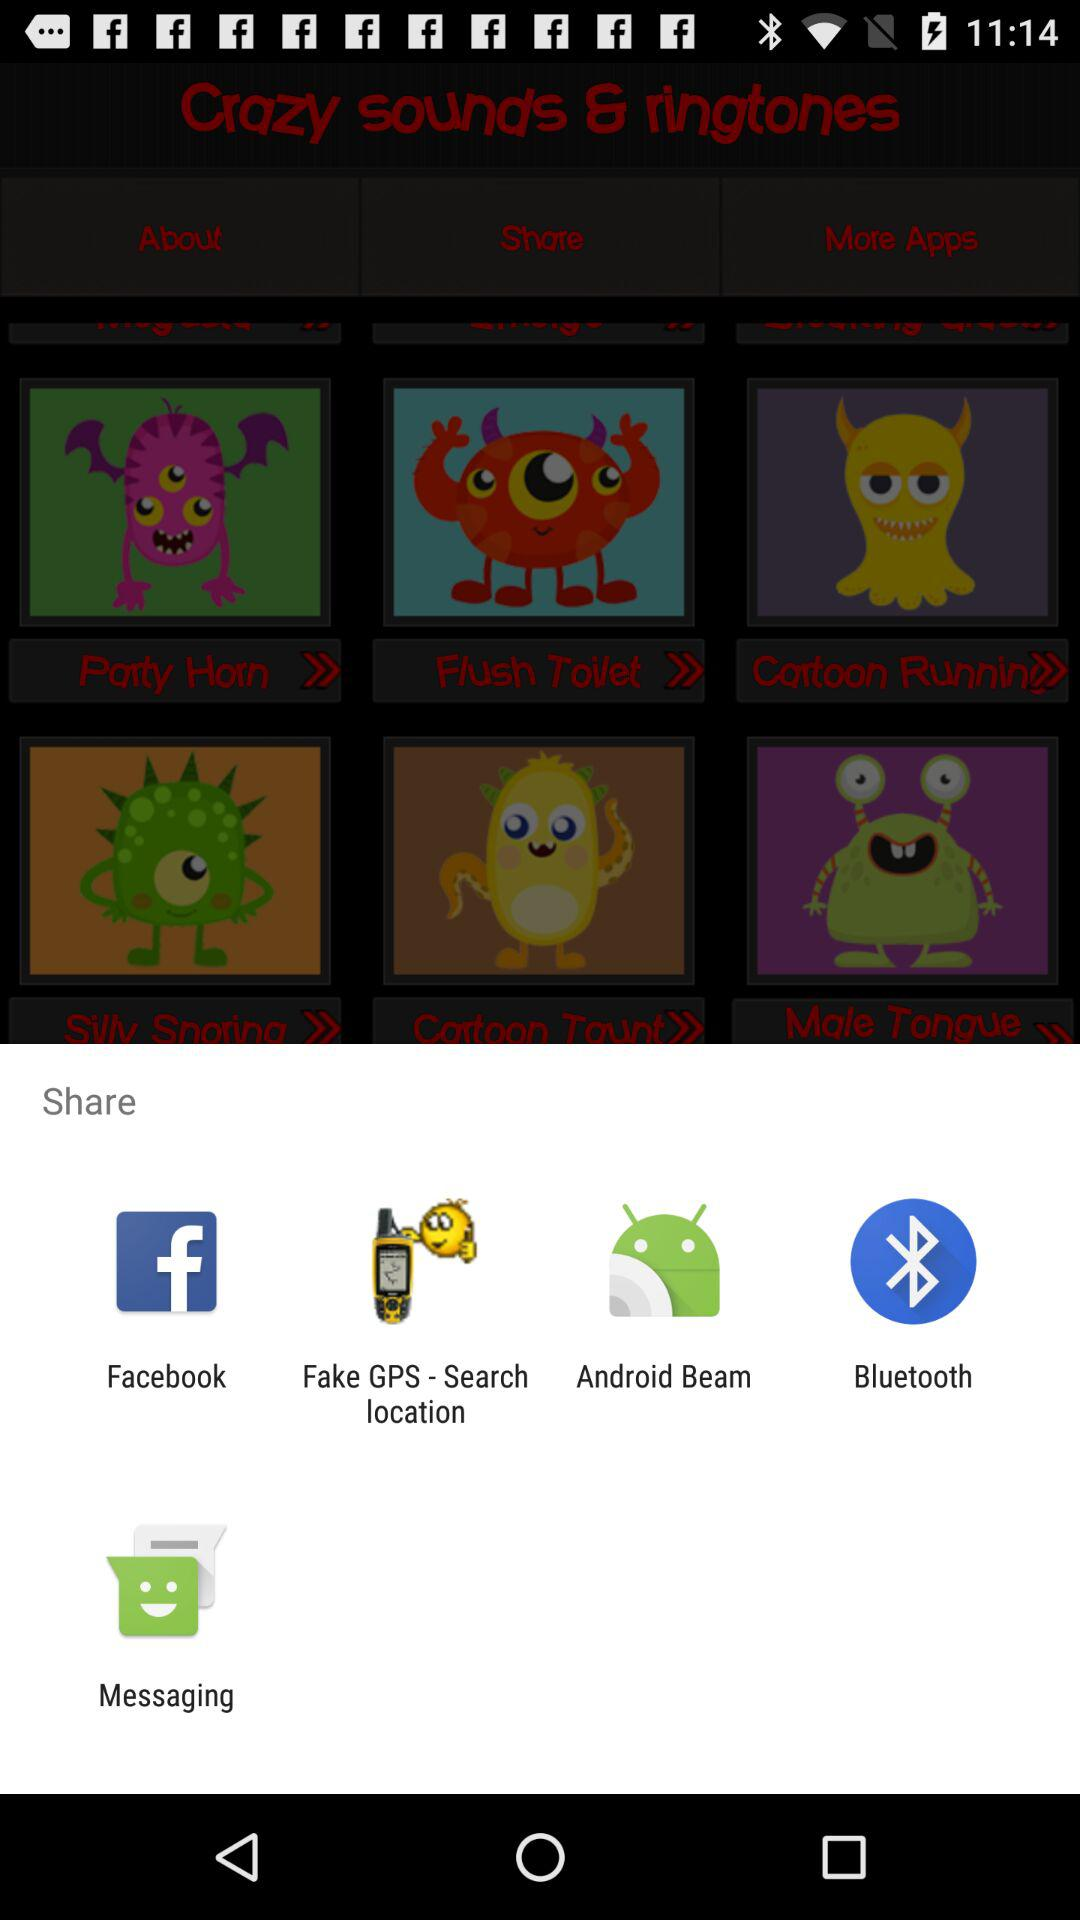Which application can I use for sharing the content? You can use "Facebook", "Fake GPS - Search location", "Android Beam", "Bluetooth" and "Messaging" for sharing the content. 